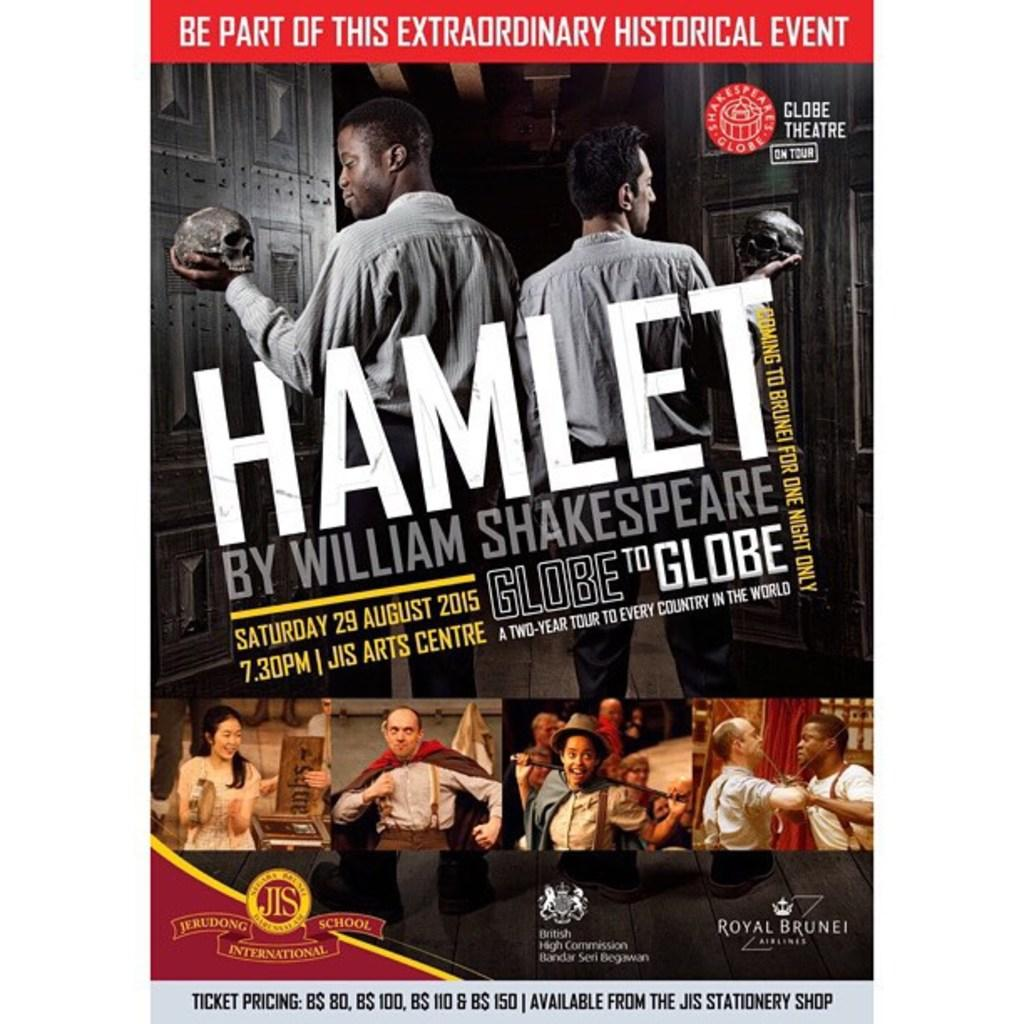<image>
Describe the image concisely. A poster for Hamlet by William Shakespere at the Globe. 